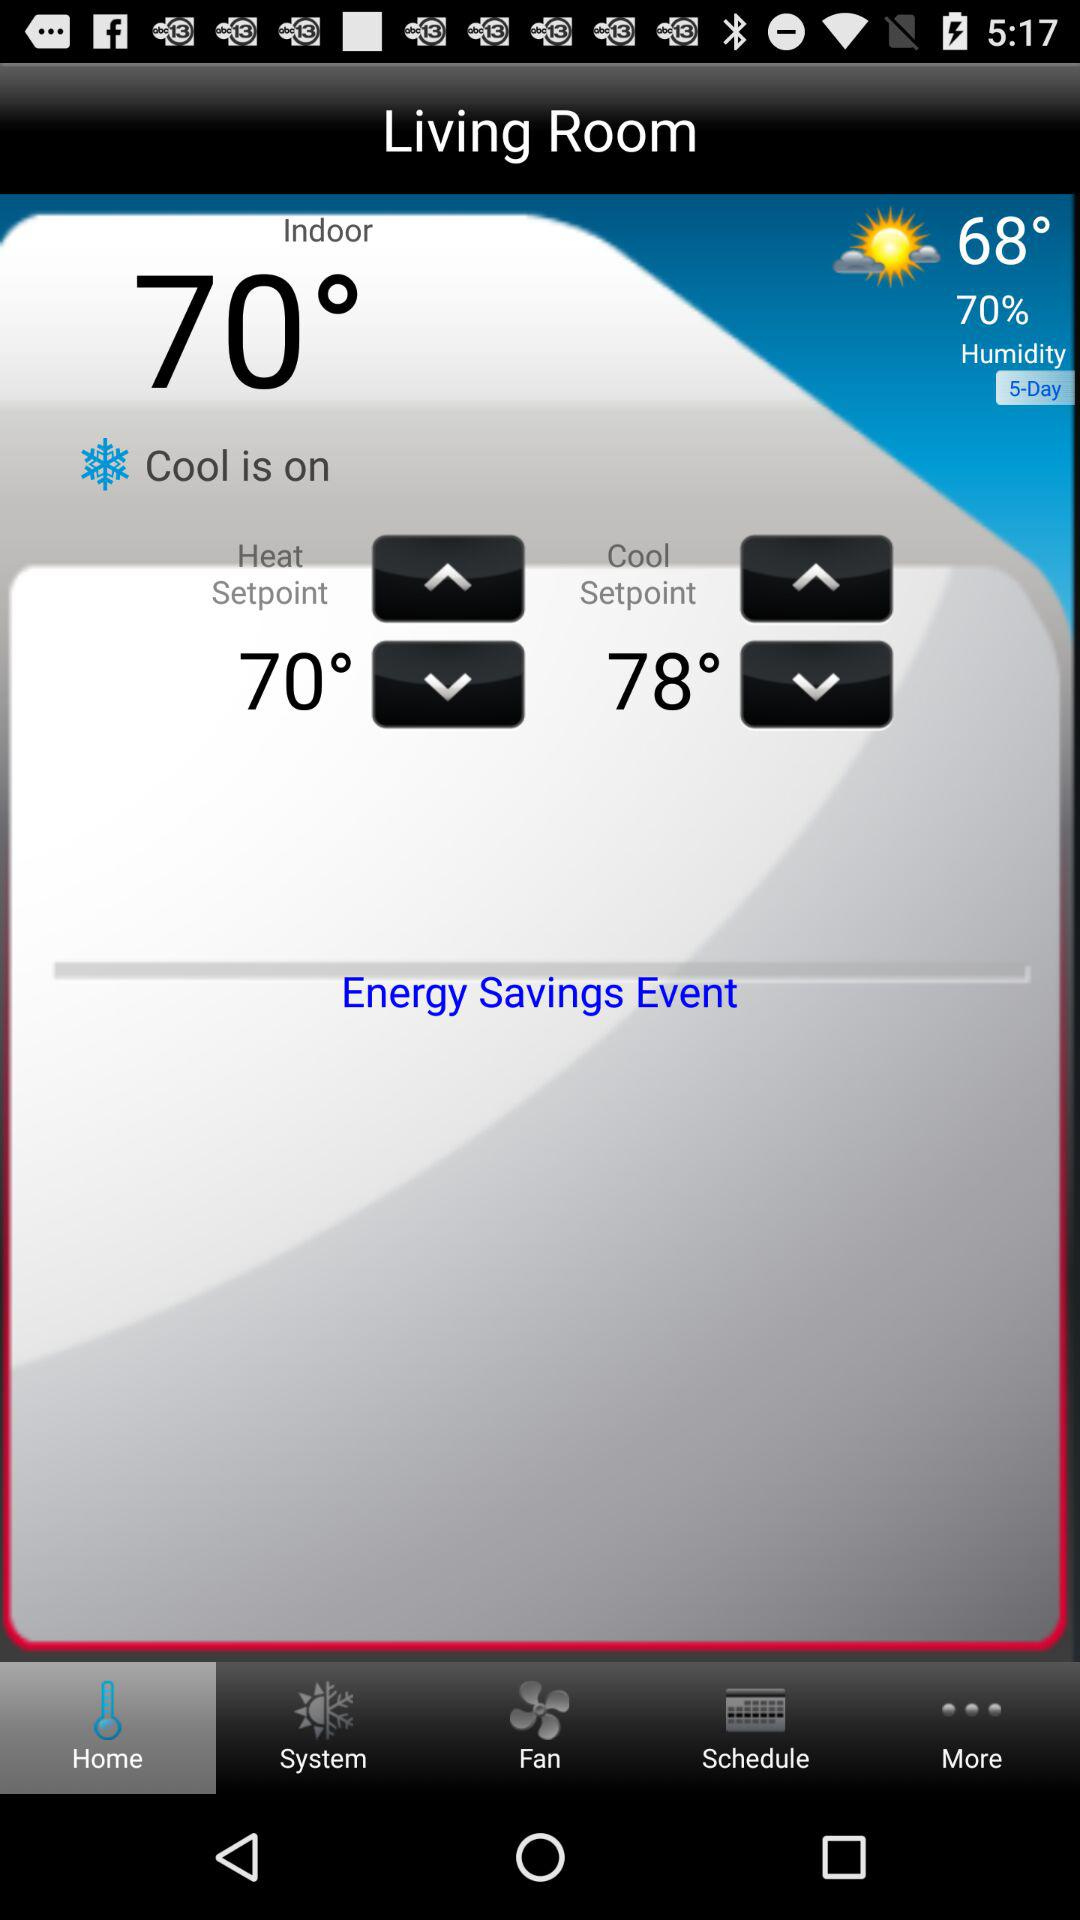What is the current indoor temperature?
Answer the question using a single word or phrase. 70° 